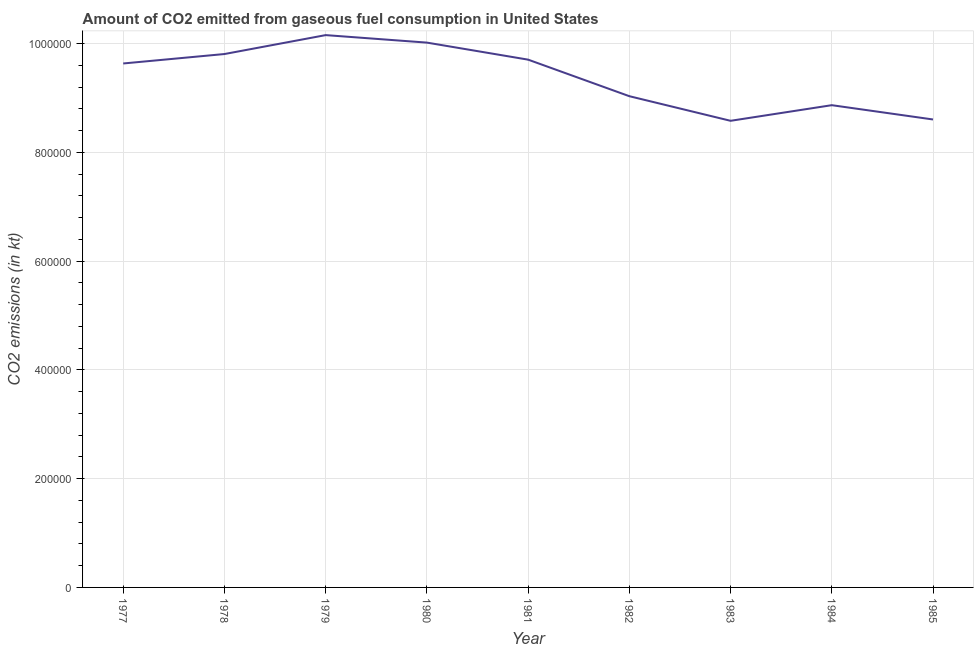What is the co2 emissions from gaseous fuel consumption in 1983?
Make the answer very short. 8.58e+05. Across all years, what is the maximum co2 emissions from gaseous fuel consumption?
Offer a terse response. 1.02e+06. Across all years, what is the minimum co2 emissions from gaseous fuel consumption?
Ensure brevity in your answer.  8.58e+05. In which year was the co2 emissions from gaseous fuel consumption maximum?
Your answer should be very brief. 1979. What is the sum of the co2 emissions from gaseous fuel consumption?
Ensure brevity in your answer.  8.44e+06. What is the difference between the co2 emissions from gaseous fuel consumption in 1980 and 1983?
Keep it short and to the point. 1.44e+05. What is the average co2 emissions from gaseous fuel consumption per year?
Offer a terse response. 9.38e+05. What is the median co2 emissions from gaseous fuel consumption?
Offer a very short reply. 9.64e+05. In how many years, is the co2 emissions from gaseous fuel consumption greater than 760000 kt?
Offer a terse response. 9. Do a majority of the years between 1977 and 1981 (inclusive) have co2 emissions from gaseous fuel consumption greater than 440000 kt?
Give a very brief answer. Yes. What is the ratio of the co2 emissions from gaseous fuel consumption in 1977 to that in 1978?
Offer a terse response. 0.98. Is the co2 emissions from gaseous fuel consumption in 1978 less than that in 1980?
Keep it short and to the point. Yes. Is the difference between the co2 emissions from gaseous fuel consumption in 1978 and 1982 greater than the difference between any two years?
Your answer should be very brief. No. What is the difference between the highest and the second highest co2 emissions from gaseous fuel consumption?
Provide a short and direct response. 1.38e+04. Is the sum of the co2 emissions from gaseous fuel consumption in 1981 and 1983 greater than the maximum co2 emissions from gaseous fuel consumption across all years?
Provide a succinct answer. Yes. What is the difference between the highest and the lowest co2 emissions from gaseous fuel consumption?
Your answer should be compact. 1.58e+05. How many lines are there?
Your answer should be compact. 1. Are the values on the major ticks of Y-axis written in scientific E-notation?
Your answer should be very brief. No. Does the graph contain any zero values?
Your answer should be compact. No. What is the title of the graph?
Offer a terse response. Amount of CO2 emitted from gaseous fuel consumption in United States. What is the label or title of the Y-axis?
Keep it short and to the point. CO2 emissions (in kt). What is the CO2 emissions (in kt) in 1977?
Offer a very short reply. 9.64e+05. What is the CO2 emissions (in kt) in 1978?
Offer a terse response. 9.81e+05. What is the CO2 emissions (in kt) of 1979?
Make the answer very short. 1.02e+06. What is the CO2 emissions (in kt) of 1980?
Offer a terse response. 1.00e+06. What is the CO2 emissions (in kt) in 1981?
Your answer should be compact. 9.71e+05. What is the CO2 emissions (in kt) in 1982?
Give a very brief answer. 9.03e+05. What is the CO2 emissions (in kt) of 1983?
Your answer should be compact. 8.58e+05. What is the CO2 emissions (in kt) in 1984?
Provide a short and direct response. 8.87e+05. What is the CO2 emissions (in kt) in 1985?
Make the answer very short. 8.61e+05. What is the difference between the CO2 emissions (in kt) in 1977 and 1978?
Keep it short and to the point. -1.74e+04. What is the difference between the CO2 emissions (in kt) in 1977 and 1979?
Make the answer very short. -5.22e+04. What is the difference between the CO2 emissions (in kt) in 1977 and 1980?
Your response must be concise. -3.84e+04. What is the difference between the CO2 emissions (in kt) in 1977 and 1981?
Your answer should be compact. -7036.97. What is the difference between the CO2 emissions (in kt) in 1977 and 1982?
Ensure brevity in your answer.  6.02e+04. What is the difference between the CO2 emissions (in kt) in 1977 and 1983?
Offer a very short reply. 1.05e+05. What is the difference between the CO2 emissions (in kt) in 1977 and 1984?
Ensure brevity in your answer.  7.67e+04. What is the difference between the CO2 emissions (in kt) in 1977 and 1985?
Your answer should be very brief. 1.03e+05. What is the difference between the CO2 emissions (in kt) in 1978 and 1979?
Offer a terse response. -3.48e+04. What is the difference between the CO2 emissions (in kt) in 1978 and 1980?
Offer a very short reply. -2.10e+04. What is the difference between the CO2 emissions (in kt) in 1978 and 1981?
Provide a short and direct response. 1.03e+04. What is the difference between the CO2 emissions (in kt) in 1978 and 1982?
Provide a succinct answer. 7.75e+04. What is the difference between the CO2 emissions (in kt) in 1978 and 1983?
Ensure brevity in your answer.  1.23e+05. What is the difference between the CO2 emissions (in kt) in 1978 and 1984?
Your answer should be compact. 9.41e+04. What is the difference between the CO2 emissions (in kt) in 1978 and 1985?
Provide a short and direct response. 1.20e+05. What is the difference between the CO2 emissions (in kt) in 1979 and 1980?
Ensure brevity in your answer.  1.38e+04. What is the difference between the CO2 emissions (in kt) in 1979 and 1981?
Keep it short and to the point. 4.51e+04. What is the difference between the CO2 emissions (in kt) in 1979 and 1982?
Provide a short and direct response. 1.12e+05. What is the difference between the CO2 emissions (in kt) in 1979 and 1983?
Your answer should be very brief. 1.58e+05. What is the difference between the CO2 emissions (in kt) in 1979 and 1984?
Provide a short and direct response. 1.29e+05. What is the difference between the CO2 emissions (in kt) in 1979 and 1985?
Your response must be concise. 1.55e+05. What is the difference between the CO2 emissions (in kt) in 1980 and 1981?
Keep it short and to the point. 3.13e+04. What is the difference between the CO2 emissions (in kt) in 1980 and 1982?
Offer a terse response. 9.86e+04. What is the difference between the CO2 emissions (in kt) in 1980 and 1983?
Make the answer very short. 1.44e+05. What is the difference between the CO2 emissions (in kt) in 1980 and 1984?
Offer a terse response. 1.15e+05. What is the difference between the CO2 emissions (in kt) in 1980 and 1985?
Your response must be concise. 1.41e+05. What is the difference between the CO2 emissions (in kt) in 1981 and 1982?
Your answer should be compact. 6.72e+04. What is the difference between the CO2 emissions (in kt) in 1981 and 1983?
Your answer should be very brief. 1.12e+05. What is the difference between the CO2 emissions (in kt) in 1981 and 1984?
Your answer should be compact. 8.38e+04. What is the difference between the CO2 emissions (in kt) in 1981 and 1985?
Offer a terse response. 1.10e+05. What is the difference between the CO2 emissions (in kt) in 1982 and 1983?
Keep it short and to the point. 4.53e+04. What is the difference between the CO2 emissions (in kt) in 1982 and 1984?
Keep it short and to the point. 1.65e+04. What is the difference between the CO2 emissions (in kt) in 1982 and 1985?
Your answer should be very brief. 4.28e+04. What is the difference between the CO2 emissions (in kt) in 1983 and 1984?
Your response must be concise. -2.87e+04. What is the difference between the CO2 emissions (in kt) in 1983 and 1985?
Keep it short and to the point. -2453.22. What is the difference between the CO2 emissions (in kt) in 1984 and 1985?
Offer a very short reply. 2.63e+04. What is the ratio of the CO2 emissions (in kt) in 1977 to that in 1979?
Ensure brevity in your answer.  0.95. What is the ratio of the CO2 emissions (in kt) in 1977 to that in 1980?
Your response must be concise. 0.96. What is the ratio of the CO2 emissions (in kt) in 1977 to that in 1982?
Your response must be concise. 1.07. What is the ratio of the CO2 emissions (in kt) in 1977 to that in 1983?
Offer a very short reply. 1.12. What is the ratio of the CO2 emissions (in kt) in 1977 to that in 1984?
Your answer should be very brief. 1.09. What is the ratio of the CO2 emissions (in kt) in 1977 to that in 1985?
Your answer should be very brief. 1.12. What is the ratio of the CO2 emissions (in kt) in 1978 to that in 1981?
Your answer should be compact. 1.01. What is the ratio of the CO2 emissions (in kt) in 1978 to that in 1982?
Give a very brief answer. 1.09. What is the ratio of the CO2 emissions (in kt) in 1978 to that in 1983?
Provide a succinct answer. 1.14. What is the ratio of the CO2 emissions (in kt) in 1978 to that in 1984?
Give a very brief answer. 1.11. What is the ratio of the CO2 emissions (in kt) in 1978 to that in 1985?
Provide a succinct answer. 1.14. What is the ratio of the CO2 emissions (in kt) in 1979 to that in 1980?
Your answer should be very brief. 1.01. What is the ratio of the CO2 emissions (in kt) in 1979 to that in 1981?
Keep it short and to the point. 1.05. What is the ratio of the CO2 emissions (in kt) in 1979 to that in 1982?
Keep it short and to the point. 1.12. What is the ratio of the CO2 emissions (in kt) in 1979 to that in 1983?
Provide a succinct answer. 1.18. What is the ratio of the CO2 emissions (in kt) in 1979 to that in 1984?
Your answer should be compact. 1.15. What is the ratio of the CO2 emissions (in kt) in 1979 to that in 1985?
Provide a short and direct response. 1.18. What is the ratio of the CO2 emissions (in kt) in 1980 to that in 1981?
Give a very brief answer. 1.03. What is the ratio of the CO2 emissions (in kt) in 1980 to that in 1982?
Ensure brevity in your answer.  1.11. What is the ratio of the CO2 emissions (in kt) in 1980 to that in 1983?
Your response must be concise. 1.17. What is the ratio of the CO2 emissions (in kt) in 1980 to that in 1984?
Your answer should be compact. 1.13. What is the ratio of the CO2 emissions (in kt) in 1980 to that in 1985?
Give a very brief answer. 1.16. What is the ratio of the CO2 emissions (in kt) in 1981 to that in 1982?
Your answer should be very brief. 1.07. What is the ratio of the CO2 emissions (in kt) in 1981 to that in 1983?
Provide a succinct answer. 1.13. What is the ratio of the CO2 emissions (in kt) in 1981 to that in 1984?
Keep it short and to the point. 1.09. What is the ratio of the CO2 emissions (in kt) in 1981 to that in 1985?
Offer a terse response. 1.13. What is the ratio of the CO2 emissions (in kt) in 1982 to that in 1983?
Keep it short and to the point. 1.05. What is the ratio of the CO2 emissions (in kt) in 1982 to that in 1985?
Offer a very short reply. 1.05. What is the ratio of the CO2 emissions (in kt) in 1983 to that in 1984?
Your answer should be compact. 0.97. What is the ratio of the CO2 emissions (in kt) in 1984 to that in 1985?
Provide a short and direct response. 1.03. 